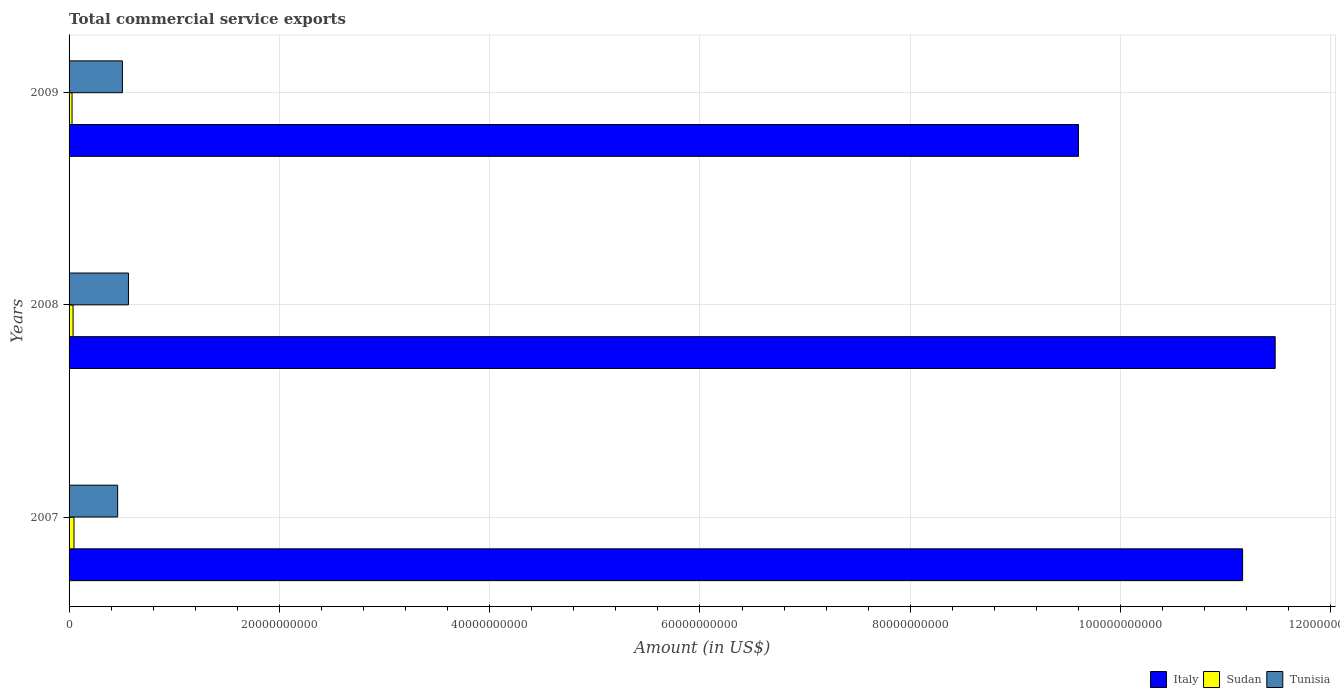How many different coloured bars are there?
Provide a short and direct response. 3. How many groups of bars are there?
Your response must be concise. 3. How many bars are there on the 1st tick from the top?
Your answer should be very brief. 3. How many bars are there on the 3rd tick from the bottom?
Offer a very short reply. 3. What is the total commercial service exports in Sudan in 2007?
Offer a very short reply. 4.68e+08. Across all years, what is the maximum total commercial service exports in Tunisia?
Make the answer very short. 5.65e+09. Across all years, what is the minimum total commercial service exports in Sudan?
Keep it short and to the point. 2.83e+08. In which year was the total commercial service exports in Sudan maximum?
Offer a very short reply. 2007. What is the total total commercial service exports in Tunisia in the graph?
Provide a short and direct response. 1.53e+1. What is the difference between the total commercial service exports in Italy in 2007 and that in 2008?
Offer a very short reply. -3.10e+09. What is the difference between the total commercial service exports in Tunisia in 2008 and the total commercial service exports in Sudan in 2007?
Ensure brevity in your answer.  5.18e+09. What is the average total commercial service exports in Italy per year?
Keep it short and to the point. 1.07e+11. In the year 2008, what is the difference between the total commercial service exports in Sudan and total commercial service exports in Italy?
Offer a terse response. -1.14e+11. What is the ratio of the total commercial service exports in Italy in 2007 to that in 2009?
Keep it short and to the point. 1.16. Is the difference between the total commercial service exports in Sudan in 2007 and 2009 greater than the difference between the total commercial service exports in Italy in 2007 and 2009?
Give a very brief answer. No. What is the difference between the highest and the second highest total commercial service exports in Italy?
Keep it short and to the point. 3.10e+09. What is the difference between the highest and the lowest total commercial service exports in Tunisia?
Provide a short and direct response. 1.03e+09. Is the sum of the total commercial service exports in Sudan in 2007 and 2008 greater than the maximum total commercial service exports in Italy across all years?
Your answer should be very brief. No. What does the 2nd bar from the top in 2007 represents?
Your response must be concise. Sudan. What does the 3rd bar from the bottom in 2009 represents?
Your answer should be very brief. Tunisia. Is it the case that in every year, the sum of the total commercial service exports in Tunisia and total commercial service exports in Sudan is greater than the total commercial service exports in Italy?
Your answer should be very brief. No. How many bars are there?
Offer a very short reply. 9. How many years are there in the graph?
Your answer should be very brief. 3. Does the graph contain any zero values?
Make the answer very short. No. Where does the legend appear in the graph?
Your response must be concise. Bottom right. How many legend labels are there?
Make the answer very short. 3. What is the title of the graph?
Give a very brief answer. Total commercial service exports. What is the label or title of the X-axis?
Your answer should be compact. Amount (in US$). What is the label or title of the Y-axis?
Give a very brief answer. Years. What is the Amount (in US$) of Italy in 2007?
Make the answer very short. 1.12e+11. What is the Amount (in US$) of Sudan in 2007?
Provide a succinct answer. 4.68e+08. What is the Amount (in US$) in Tunisia in 2007?
Your answer should be compact. 4.62e+09. What is the Amount (in US$) of Italy in 2008?
Provide a succinct answer. 1.15e+11. What is the Amount (in US$) in Sudan in 2008?
Provide a succinct answer. 3.82e+08. What is the Amount (in US$) in Tunisia in 2008?
Your answer should be very brief. 5.65e+09. What is the Amount (in US$) in Italy in 2009?
Make the answer very short. 9.60e+1. What is the Amount (in US$) in Sudan in 2009?
Provide a succinct answer. 2.83e+08. What is the Amount (in US$) of Tunisia in 2009?
Ensure brevity in your answer.  5.08e+09. Across all years, what is the maximum Amount (in US$) in Italy?
Provide a short and direct response. 1.15e+11. Across all years, what is the maximum Amount (in US$) in Sudan?
Your answer should be very brief. 4.68e+08. Across all years, what is the maximum Amount (in US$) of Tunisia?
Give a very brief answer. 5.65e+09. Across all years, what is the minimum Amount (in US$) in Italy?
Your answer should be very brief. 9.60e+1. Across all years, what is the minimum Amount (in US$) of Sudan?
Your answer should be very brief. 2.83e+08. Across all years, what is the minimum Amount (in US$) of Tunisia?
Keep it short and to the point. 4.62e+09. What is the total Amount (in US$) of Italy in the graph?
Offer a terse response. 3.22e+11. What is the total Amount (in US$) in Sudan in the graph?
Keep it short and to the point. 1.13e+09. What is the total Amount (in US$) of Tunisia in the graph?
Your response must be concise. 1.53e+1. What is the difference between the Amount (in US$) in Italy in 2007 and that in 2008?
Your answer should be very brief. -3.10e+09. What is the difference between the Amount (in US$) in Sudan in 2007 and that in 2008?
Make the answer very short. 8.61e+07. What is the difference between the Amount (in US$) in Tunisia in 2007 and that in 2008?
Make the answer very short. -1.03e+09. What is the difference between the Amount (in US$) in Italy in 2007 and that in 2009?
Give a very brief answer. 1.56e+1. What is the difference between the Amount (in US$) in Sudan in 2007 and that in 2009?
Your response must be concise. 1.84e+08. What is the difference between the Amount (in US$) in Tunisia in 2007 and that in 2009?
Provide a short and direct response. -4.56e+08. What is the difference between the Amount (in US$) of Italy in 2008 and that in 2009?
Offer a very short reply. 1.87e+1. What is the difference between the Amount (in US$) of Sudan in 2008 and that in 2009?
Provide a succinct answer. 9.83e+07. What is the difference between the Amount (in US$) of Tunisia in 2008 and that in 2009?
Provide a short and direct response. 5.73e+08. What is the difference between the Amount (in US$) in Italy in 2007 and the Amount (in US$) in Sudan in 2008?
Provide a succinct answer. 1.11e+11. What is the difference between the Amount (in US$) in Italy in 2007 and the Amount (in US$) in Tunisia in 2008?
Your answer should be compact. 1.06e+11. What is the difference between the Amount (in US$) of Sudan in 2007 and the Amount (in US$) of Tunisia in 2008?
Provide a short and direct response. -5.18e+09. What is the difference between the Amount (in US$) in Italy in 2007 and the Amount (in US$) in Sudan in 2009?
Offer a very short reply. 1.11e+11. What is the difference between the Amount (in US$) in Italy in 2007 and the Amount (in US$) in Tunisia in 2009?
Offer a terse response. 1.07e+11. What is the difference between the Amount (in US$) of Sudan in 2007 and the Amount (in US$) of Tunisia in 2009?
Make the answer very short. -4.61e+09. What is the difference between the Amount (in US$) in Italy in 2008 and the Amount (in US$) in Sudan in 2009?
Your answer should be very brief. 1.14e+11. What is the difference between the Amount (in US$) of Italy in 2008 and the Amount (in US$) of Tunisia in 2009?
Offer a terse response. 1.10e+11. What is the difference between the Amount (in US$) in Sudan in 2008 and the Amount (in US$) in Tunisia in 2009?
Offer a terse response. -4.69e+09. What is the average Amount (in US$) in Italy per year?
Offer a very short reply. 1.07e+11. What is the average Amount (in US$) of Sudan per year?
Your response must be concise. 3.78e+08. What is the average Amount (in US$) in Tunisia per year?
Your response must be concise. 5.11e+09. In the year 2007, what is the difference between the Amount (in US$) of Italy and Amount (in US$) of Sudan?
Offer a terse response. 1.11e+11. In the year 2007, what is the difference between the Amount (in US$) in Italy and Amount (in US$) in Tunisia?
Your answer should be very brief. 1.07e+11. In the year 2007, what is the difference between the Amount (in US$) in Sudan and Amount (in US$) in Tunisia?
Offer a very short reply. -4.15e+09. In the year 2008, what is the difference between the Amount (in US$) in Italy and Amount (in US$) in Sudan?
Keep it short and to the point. 1.14e+11. In the year 2008, what is the difference between the Amount (in US$) in Italy and Amount (in US$) in Tunisia?
Offer a very short reply. 1.09e+11. In the year 2008, what is the difference between the Amount (in US$) of Sudan and Amount (in US$) of Tunisia?
Make the answer very short. -5.27e+09. In the year 2009, what is the difference between the Amount (in US$) of Italy and Amount (in US$) of Sudan?
Offer a very short reply. 9.57e+1. In the year 2009, what is the difference between the Amount (in US$) of Italy and Amount (in US$) of Tunisia?
Your answer should be compact. 9.09e+1. In the year 2009, what is the difference between the Amount (in US$) in Sudan and Amount (in US$) in Tunisia?
Your answer should be very brief. -4.79e+09. What is the ratio of the Amount (in US$) in Sudan in 2007 to that in 2008?
Offer a terse response. 1.23. What is the ratio of the Amount (in US$) in Tunisia in 2007 to that in 2008?
Your response must be concise. 0.82. What is the ratio of the Amount (in US$) of Italy in 2007 to that in 2009?
Give a very brief answer. 1.16. What is the ratio of the Amount (in US$) in Sudan in 2007 to that in 2009?
Provide a succinct answer. 1.65. What is the ratio of the Amount (in US$) of Tunisia in 2007 to that in 2009?
Offer a terse response. 0.91. What is the ratio of the Amount (in US$) of Italy in 2008 to that in 2009?
Offer a very short reply. 1.19. What is the ratio of the Amount (in US$) in Sudan in 2008 to that in 2009?
Provide a short and direct response. 1.35. What is the ratio of the Amount (in US$) of Tunisia in 2008 to that in 2009?
Keep it short and to the point. 1.11. What is the difference between the highest and the second highest Amount (in US$) in Italy?
Provide a short and direct response. 3.10e+09. What is the difference between the highest and the second highest Amount (in US$) in Sudan?
Keep it short and to the point. 8.61e+07. What is the difference between the highest and the second highest Amount (in US$) in Tunisia?
Give a very brief answer. 5.73e+08. What is the difference between the highest and the lowest Amount (in US$) of Italy?
Give a very brief answer. 1.87e+1. What is the difference between the highest and the lowest Amount (in US$) of Sudan?
Give a very brief answer. 1.84e+08. What is the difference between the highest and the lowest Amount (in US$) of Tunisia?
Make the answer very short. 1.03e+09. 